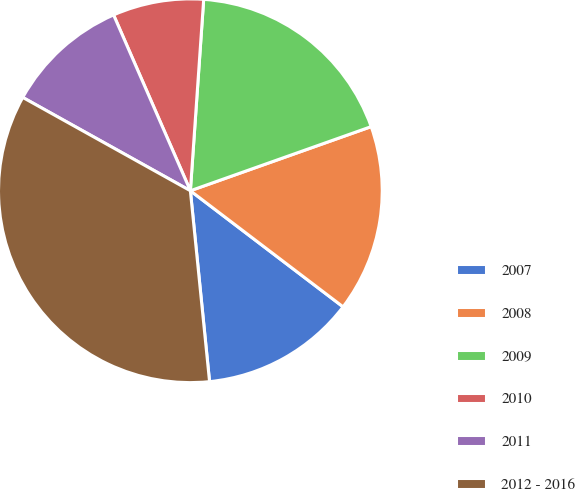Convert chart to OTSL. <chart><loc_0><loc_0><loc_500><loc_500><pie_chart><fcel>2007<fcel>2008<fcel>2009<fcel>2010<fcel>2011<fcel>2012 - 2016<nl><fcel>13.06%<fcel>15.77%<fcel>18.47%<fcel>7.66%<fcel>10.36%<fcel>34.68%<nl></chart> 